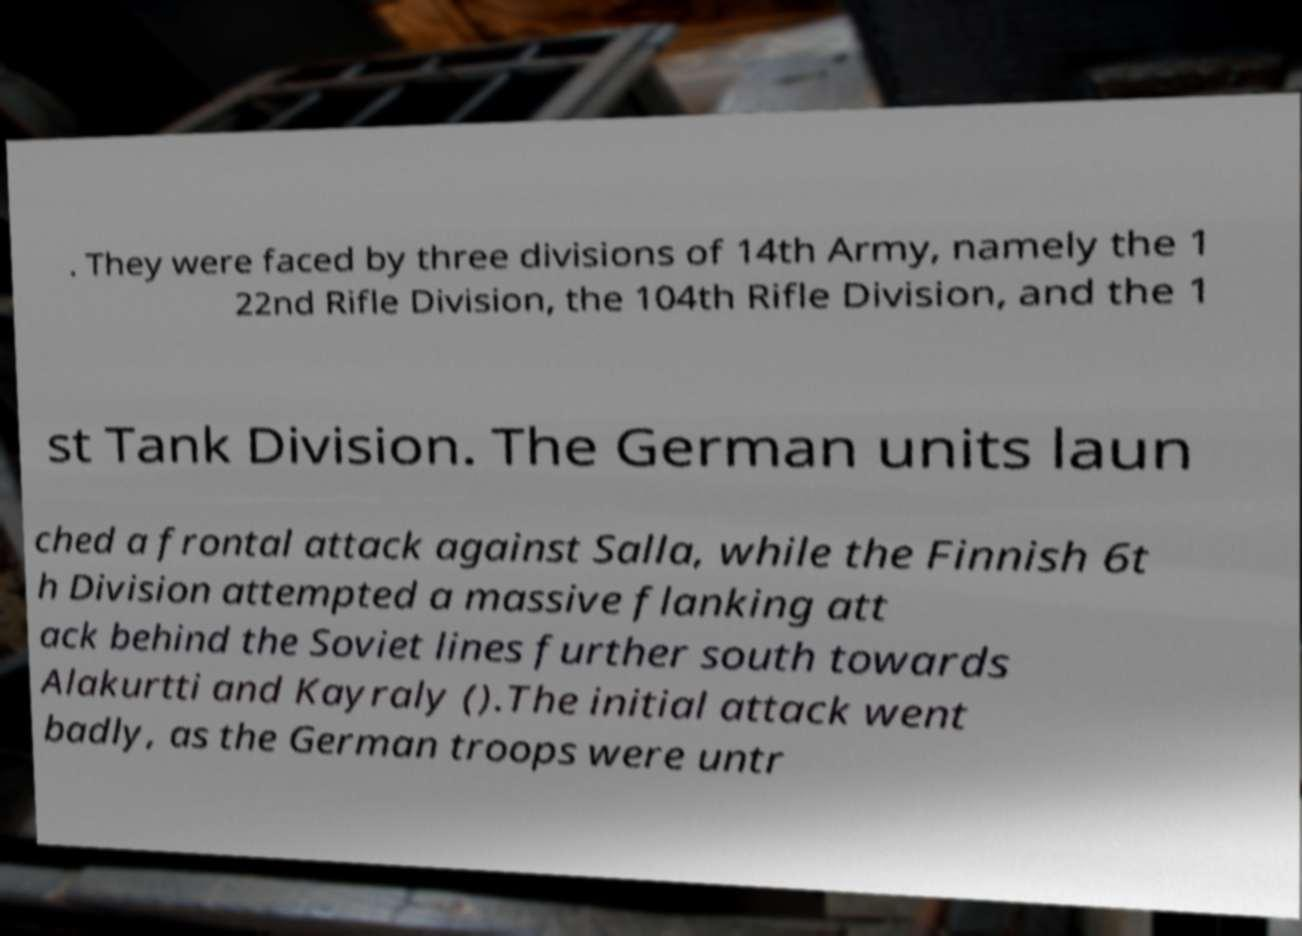What messages or text are displayed in this image? I need them in a readable, typed format. . They were faced by three divisions of 14th Army, namely the 1 22nd Rifle Division, the 104th Rifle Division, and the 1 st Tank Division. The German units laun ched a frontal attack against Salla, while the Finnish 6t h Division attempted a massive flanking att ack behind the Soviet lines further south towards Alakurtti and Kayraly ().The initial attack went badly, as the German troops were untr 